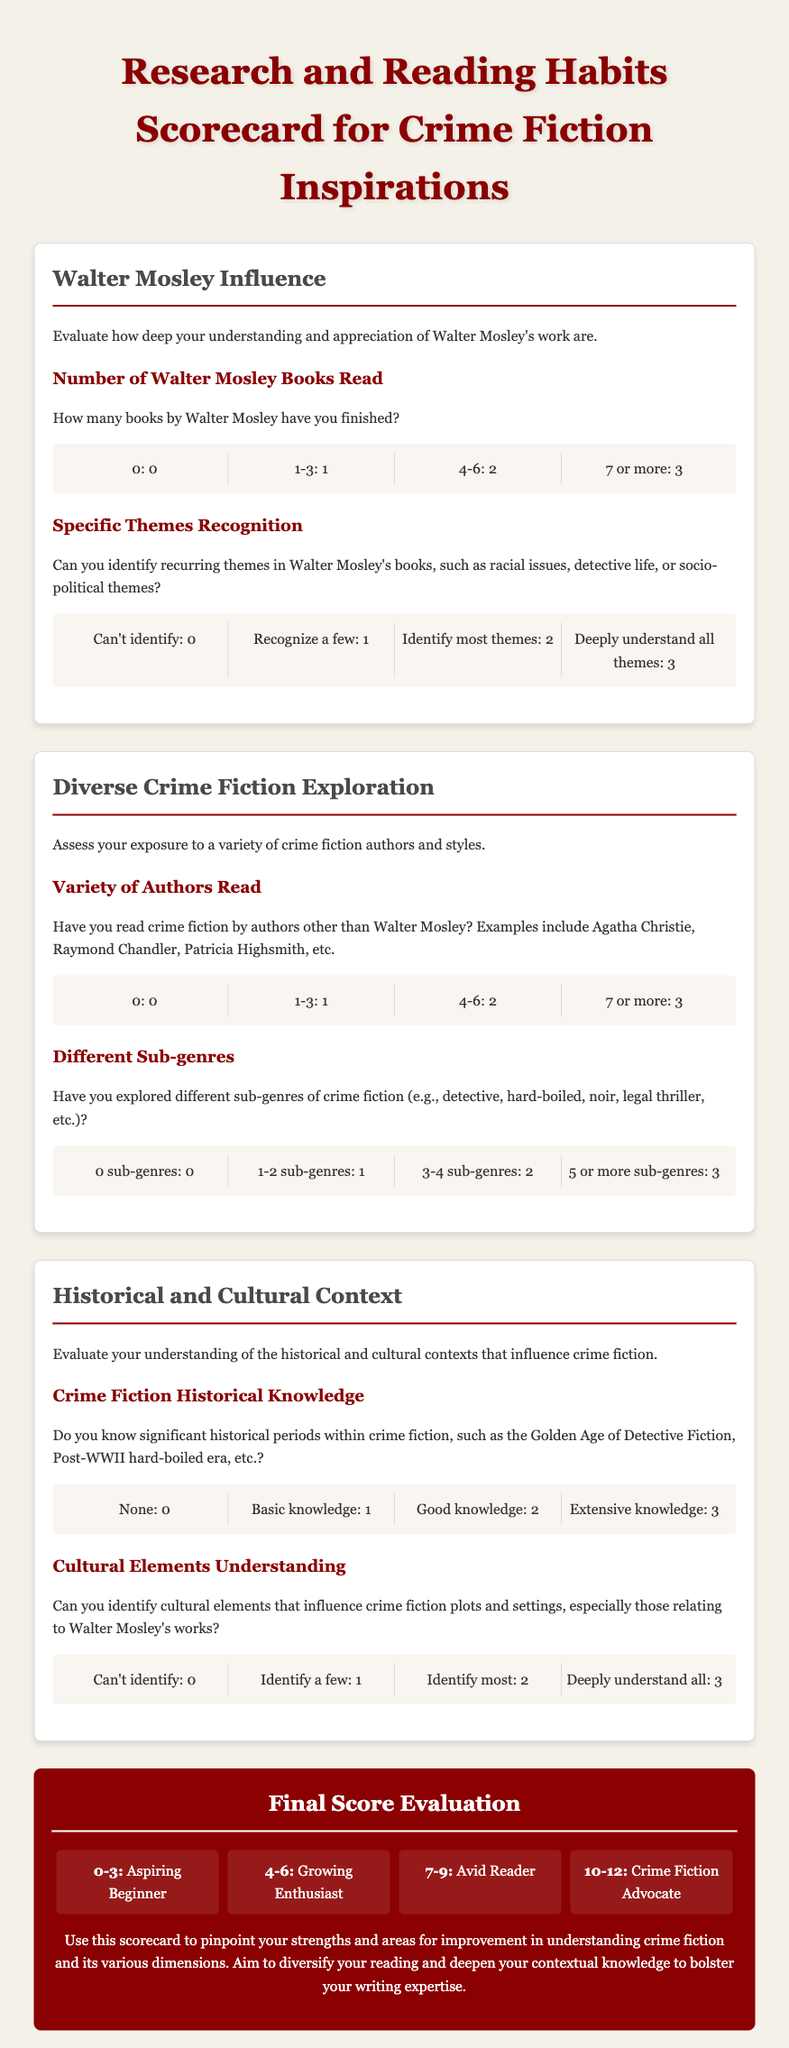What is the title of the scorecard? The title of the scorecard is the header of the document and states its purpose clearly.
Answer: Research and Reading Habits Scorecard for Crime Fiction Inspirations How many categories are included in the scorecard? The scorecard divides the content into various sections, which represent different areas of focus for the reader.
Answer: Three What is the maximum score for the "Walter Mosley Influence" section? The scoring in the section indicates the highest possible points one can achieve based on their responses.
Answer: 6 Which sub-genre has the lowest score range in the "Different Sub-genres" criteria? The criteria indicate sub-genres and their corresponding score ranges for knowledge assessment among readers.
Answer: 0 sub-genres What score range identifies someone as an "Avid Reader"? The answer can be found in the final score evaluation which summarizes different score ranges and what they signify.
Answer: 7-9 What is the minimum score for the "Cultural Elements Understanding" criterion? The first scoring option listed in the assessment provides the lowest achievable score.
Answer: 0 Identify an author mentioned for variety in the "Variety of Authors Read" section. The section references notable crime fiction authors that could broaden a reader's experience.
Answer: Agatha Christie What is the range for a "Crime Fiction Advocate"? The final score evaluation categorizes readers based on specific score ranges reflecting their expertise and engagement level.
Answer: 10-12 